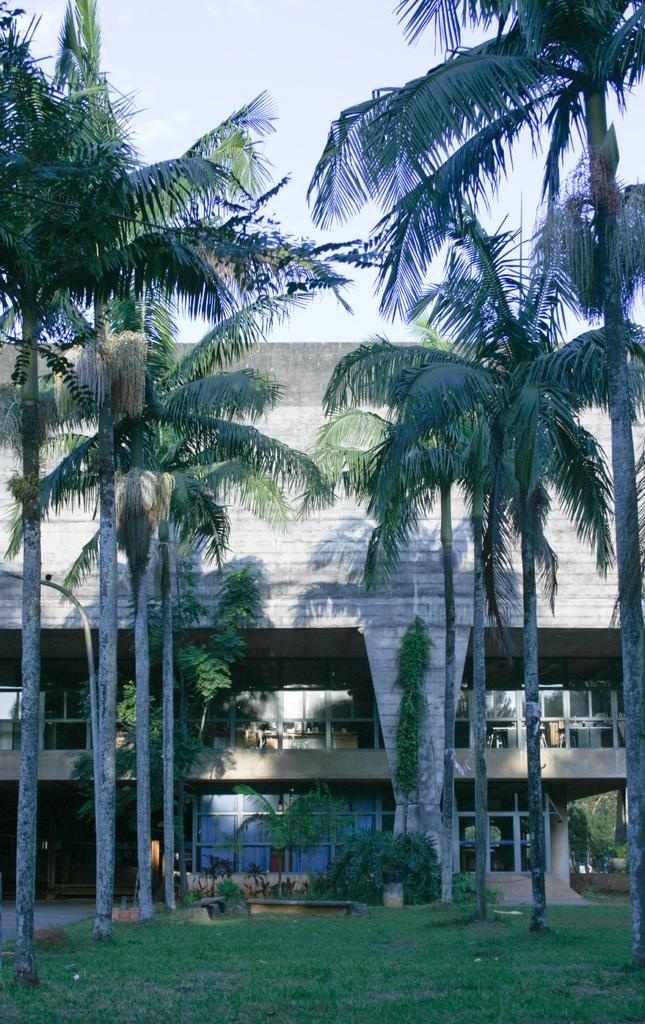What is the main structure in the picture? There is a building in the picture. What can be seen in front of the building? There are trees and grass in front of the building. What color are the eyes of the tomatoes in the picture? There are no tomatoes present in the image, so there are no eyes to describe. 